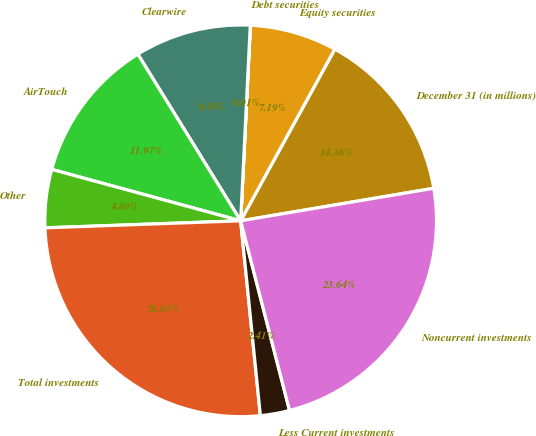Convert chart to OTSL. <chart><loc_0><loc_0><loc_500><loc_500><pie_chart><fcel>December 31 (in millions)<fcel>Equity securities<fcel>Debt securities<fcel>Clearwire<fcel>AirTouch<fcel>Other<fcel>Total investments<fcel>Less Current investments<fcel>Noncurrent investments<nl><fcel>14.36%<fcel>7.19%<fcel>0.01%<fcel>9.58%<fcel>11.97%<fcel>4.8%<fcel>26.03%<fcel>2.41%<fcel>23.64%<nl></chart> 